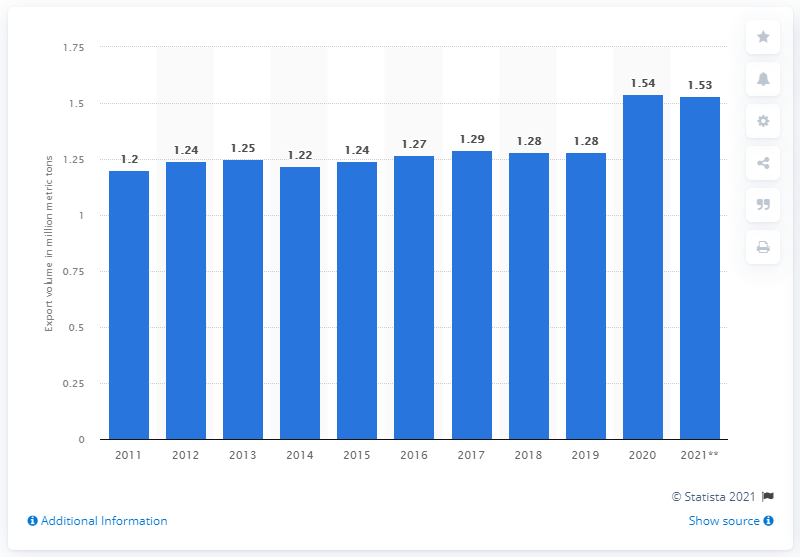Give some essential details in this illustration. In 2020, the export volume of pork from Canada was 1.53 million metric tons. 